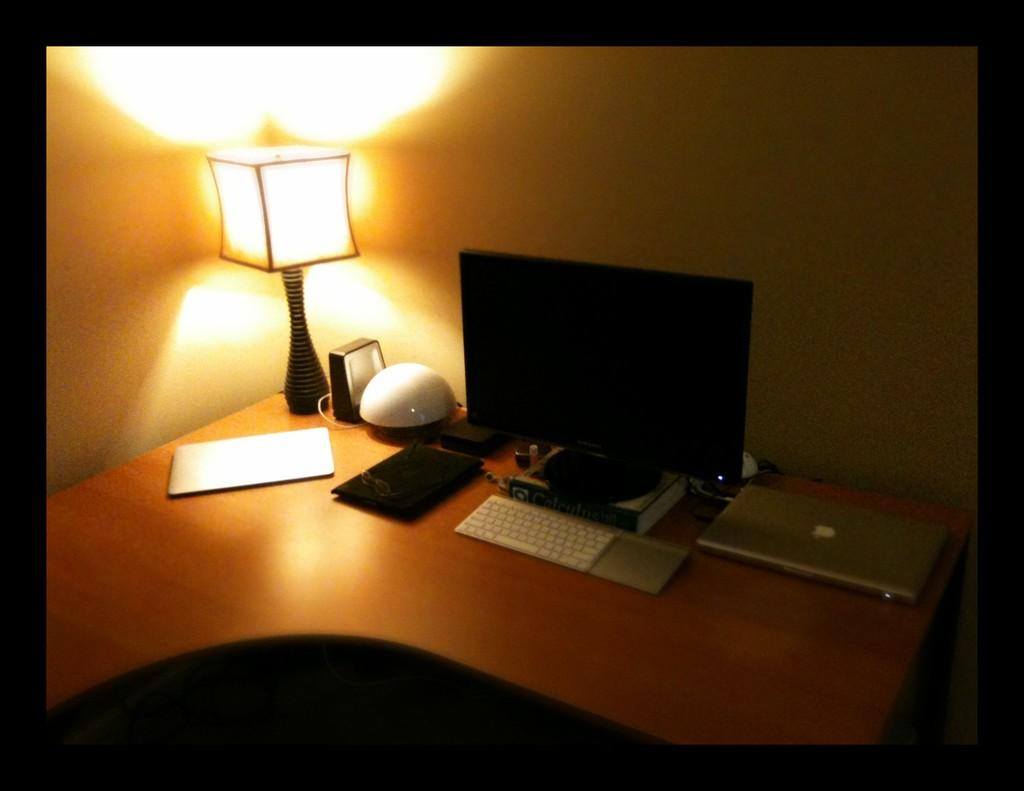What type of table is in the image? There is a wooden table in the image. What can be seen on the table? There are items placed on the table. What is visible behind the table in the image? There is a wall visible at the back side of the image. How many apples are being read by the chin in the image? There are no apples or chins present in the image. 